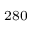<formula> <loc_0><loc_0><loc_500><loc_500>^ { 2 8 0 }</formula> 